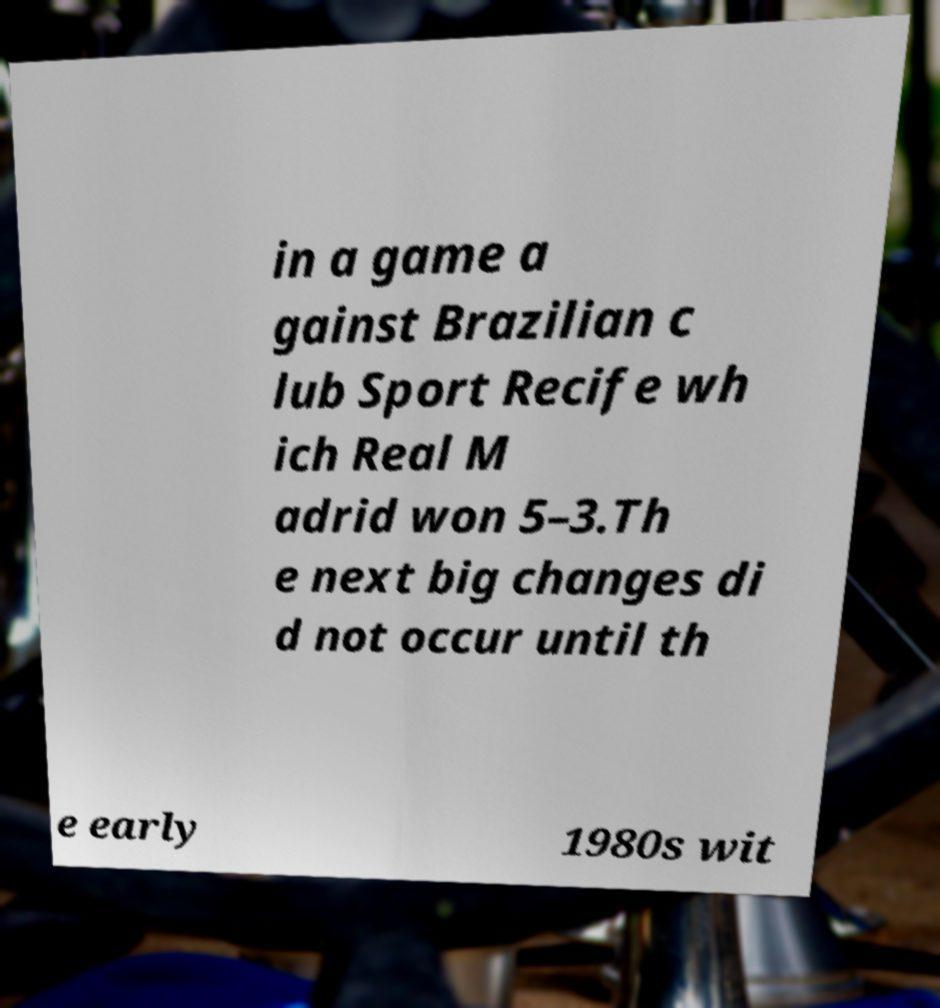Could you assist in decoding the text presented in this image and type it out clearly? in a game a gainst Brazilian c lub Sport Recife wh ich Real M adrid won 5–3.Th e next big changes di d not occur until th e early 1980s wit 